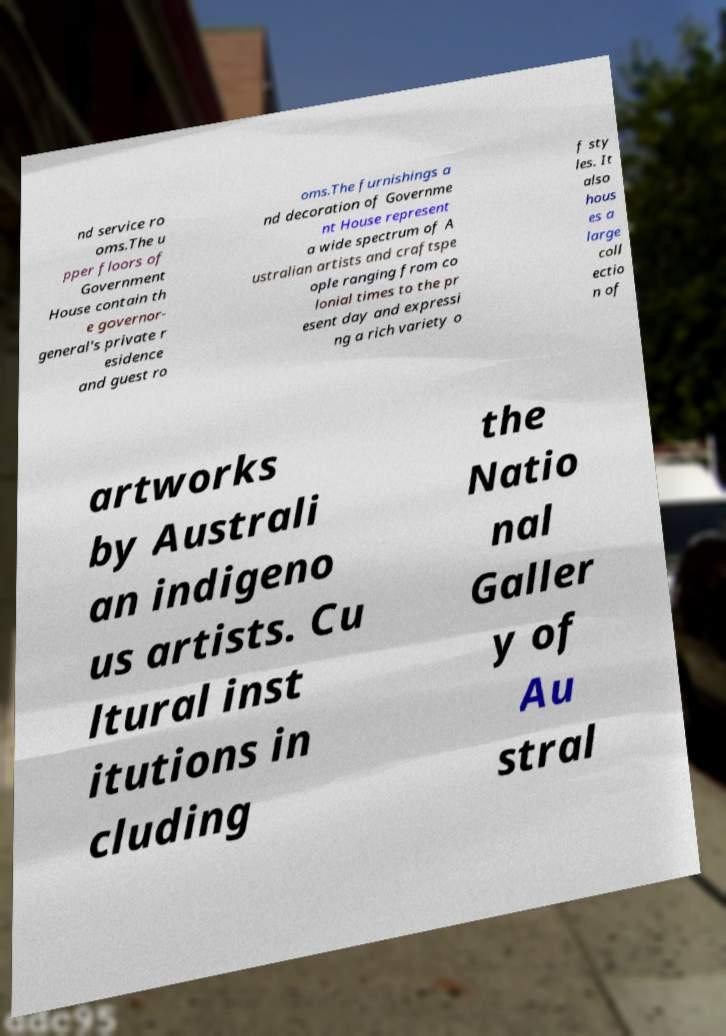What messages or text are displayed in this image? I need them in a readable, typed format. nd service ro oms.The u pper floors of Government House contain th e governor- general's private r esidence and guest ro oms.The furnishings a nd decoration of Governme nt House represent a wide spectrum of A ustralian artists and craftspe ople ranging from co lonial times to the pr esent day and expressi ng a rich variety o f sty les. It also hous es a large coll ectio n of artworks by Australi an indigeno us artists. Cu ltural inst itutions in cluding the Natio nal Galler y of Au stral 